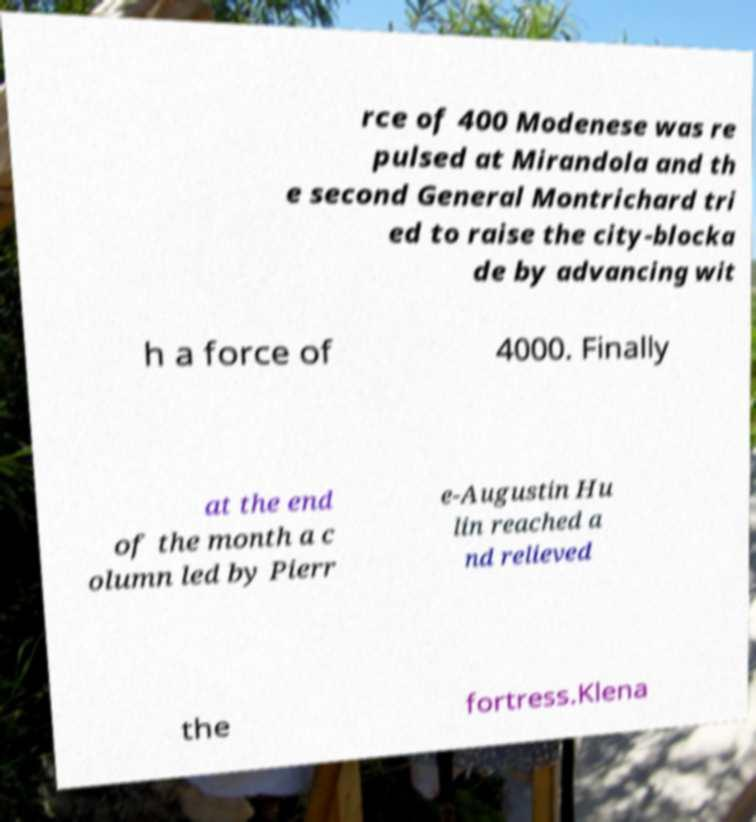There's text embedded in this image that I need extracted. Can you transcribe it verbatim? rce of 400 Modenese was re pulsed at Mirandola and th e second General Montrichard tri ed to raise the city-blocka de by advancing wit h a force of 4000. Finally at the end of the month a c olumn led by Pierr e-Augustin Hu lin reached a nd relieved the fortress.Klena 